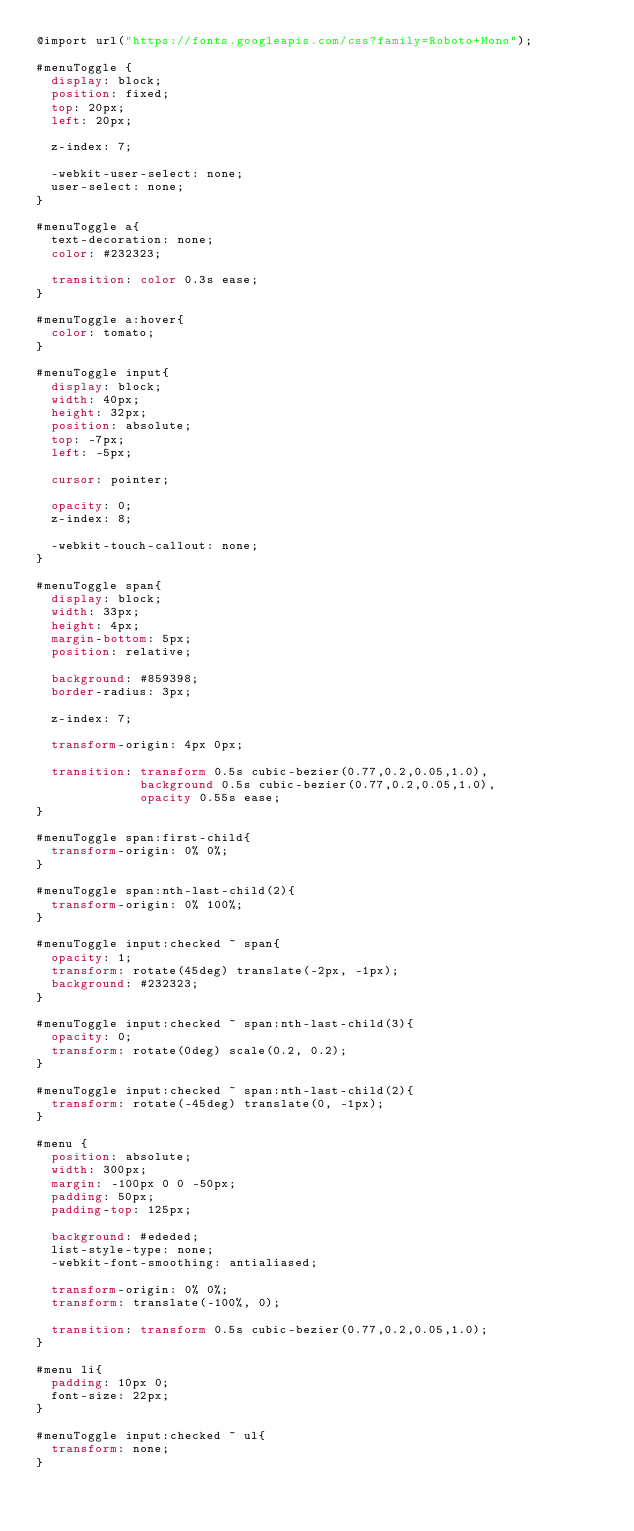<code> <loc_0><loc_0><loc_500><loc_500><_CSS_>@import url("https://fonts.googleapis.com/css?family=Roboto+Mono");

#menuToggle {
  display: block;
  position: fixed;
  top: 20px;
  left: 20px;

  z-index: 7;

  -webkit-user-select: none;
  user-select: none;
}

#menuToggle a{
  text-decoration: none;
  color: #232323;

  transition: color 0.3s ease;
}

#menuToggle a:hover{
  color: tomato;
}

#menuToggle input{
  display: block;
  width: 40px;
  height: 32px;
  position: absolute;
  top: -7px;
  left: -5px;

  cursor: pointer;

  opacity: 0;
  z-index: 8;

  -webkit-touch-callout: none;
}

#menuToggle span{
  display: block;
  width: 33px;
  height: 4px;
  margin-bottom: 5px;
  position: relative;

  background: #859398;
  border-radius: 3px;

  z-index: 7;

  transform-origin: 4px 0px;

  transition: transform 0.5s cubic-bezier(0.77,0.2,0.05,1.0),
              background 0.5s cubic-bezier(0.77,0.2,0.05,1.0),
              opacity 0.55s ease;
}

#menuToggle span:first-child{
  transform-origin: 0% 0%;
}

#menuToggle span:nth-last-child(2){
  transform-origin: 0% 100%;
}

#menuToggle input:checked ~ span{
  opacity: 1;
  transform: rotate(45deg) translate(-2px, -1px);
  background: #232323;
}

#menuToggle input:checked ~ span:nth-last-child(3){
  opacity: 0;
  transform: rotate(0deg) scale(0.2, 0.2);
}

#menuToggle input:checked ~ span:nth-last-child(2){
  transform: rotate(-45deg) translate(0, -1px);
}

#menu {
  position: absolute;
  width: 300px;
  margin: -100px 0 0 -50px;
  padding: 50px;
  padding-top: 125px;

  background: #ededed;
  list-style-type: none;
  -webkit-font-smoothing: antialiased;

  transform-origin: 0% 0%;
  transform: translate(-100%, 0);

  transition: transform 0.5s cubic-bezier(0.77,0.2,0.05,1.0);
}

#menu li{
  padding: 10px 0;
  font-size: 22px;
}

#menuToggle input:checked ~ ul{
  transform: none;
}
</code> 